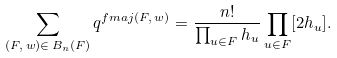Convert formula to latex. <formula><loc_0><loc_0><loc_500><loc_500>\sum _ { ( F , \, w ) \in \, B _ { n } ( F ) } q ^ { f m a j ( F , \, w ) } = \frac { n ! } { \prod _ { u \in F } h _ { u } } \prod _ { u \in F } [ 2 h _ { u } ] .</formula> 